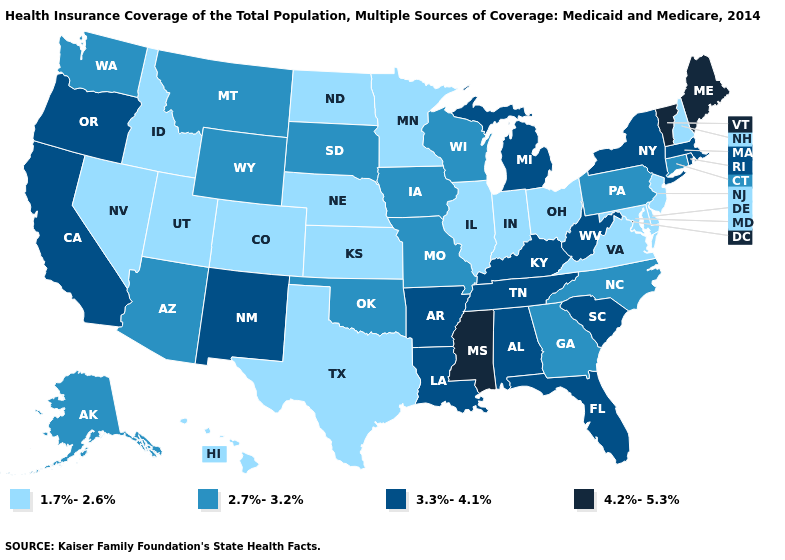Name the states that have a value in the range 4.2%-5.3%?
Keep it brief. Maine, Mississippi, Vermont. Name the states that have a value in the range 1.7%-2.6%?
Quick response, please. Colorado, Delaware, Hawaii, Idaho, Illinois, Indiana, Kansas, Maryland, Minnesota, Nebraska, Nevada, New Hampshire, New Jersey, North Dakota, Ohio, Texas, Utah, Virginia. What is the highest value in states that border Michigan?
Keep it brief. 2.7%-3.2%. Does the first symbol in the legend represent the smallest category?
Be succinct. Yes. Name the states that have a value in the range 4.2%-5.3%?
Short answer required. Maine, Mississippi, Vermont. What is the highest value in states that border Maryland?
Be succinct. 3.3%-4.1%. Among the states that border Montana , does Idaho have the highest value?
Write a very short answer. No. What is the highest value in the Northeast ?
Concise answer only. 4.2%-5.3%. Name the states that have a value in the range 2.7%-3.2%?
Keep it brief. Alaska, Arizona, Connecticut, Georgia, Iowa, Missouri, Montana, North Carolina, Oklahoma, Pennsylvania, South Dakota, Washington, Wisconsin, Wyoming. What is the lowest value in the Northeast?
Keep it brief. 1.7%-2.6%. Does New Jersey have the lowest value in the USA?
Be succinct. Yes. Does Kansas have the lowest value in the MidWest?
Write a very short answer. Yes. Name the states that have a value in the range 1.7%-2.6%?
Answer briefly. Colorado, Delaware, Hawaii, Idaho, Illinois, Indiana, Kansas, Maryland, Minnesota, Nebraska, Nevada, New Hampshire, New Jersey, North Dakota, Ohio, Texas, Utah, Virginia. Name the states that have a value in the range 4.2%-5.3%?
Concise answer only. Maine, Mississippi, Vermont. Does Alaska have a higher value than South Carolina?
Give a very brief answer. No. 